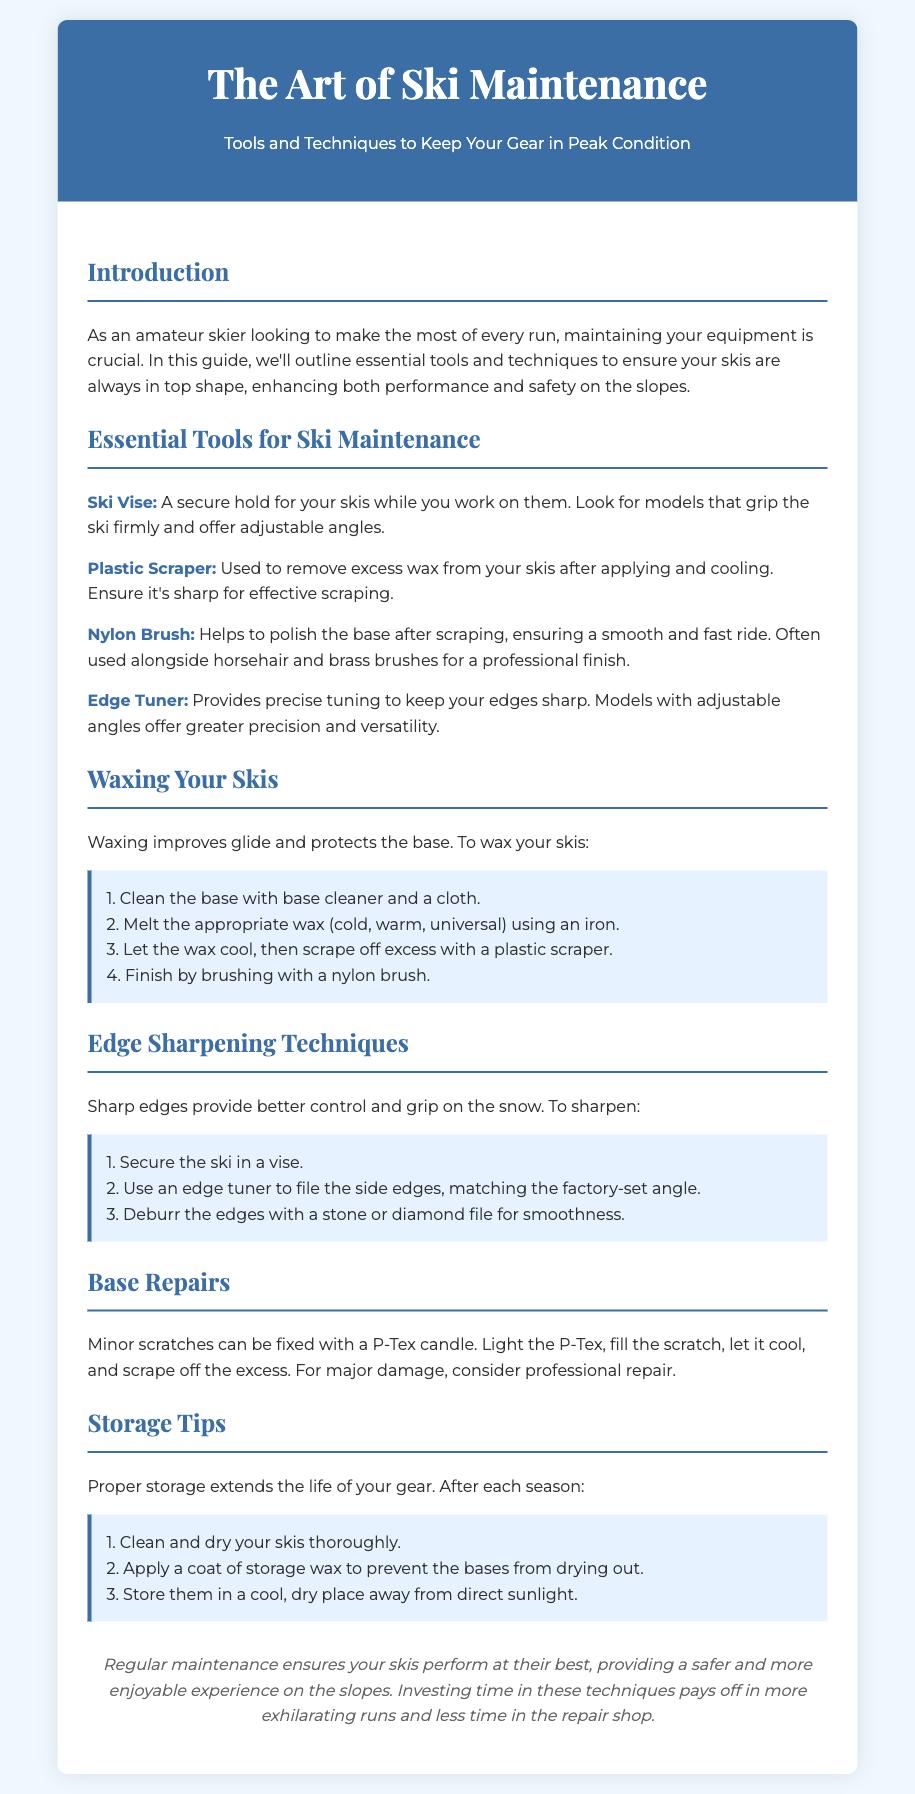What is the title of the document? The title of the document is mentioned at the top as "The Art of Ski Maintenance."
Answer: The Art of Ski Maintenance What is the primary focus of the guide? The primary focus of the guide is to provide tools and techniques to maintain ski gear.
Answer: Tools and techniques to keep your gear in peak condition How many steps are listed for waxing skis? The document outlines four steps for waxing skis.
Answer: Four What tool is necessary for securing skis during maintenance? The document mentions the "Ski Vise" as a necessary tool.
Answer: Ski Vise What is used for polishing the ski base after scraping? The document states that a "Nylon Brush" is used for polishing.
Answer: Nylon Brush What is the first step in the edge sharpening process? The first step in the edge sharpening process is to secure the ski in a vise.
Answer: Secure the ski in a vise How should skis be stored after the season? The document advises to clean, apply storage wax, and store them in a cool, dry place.
Answer: Clean and dry; apply storage wax; store in a cool, dry place What is P-Tex used for? P-Tex is used to fix minor scratches on the ski base.
Answer: Fixing minor scratches What should be done to skis before applying storage wax? Skis should be cleaned and dried thoroughly before applying storage wax.
Answer: Clean and dry thoroughly 